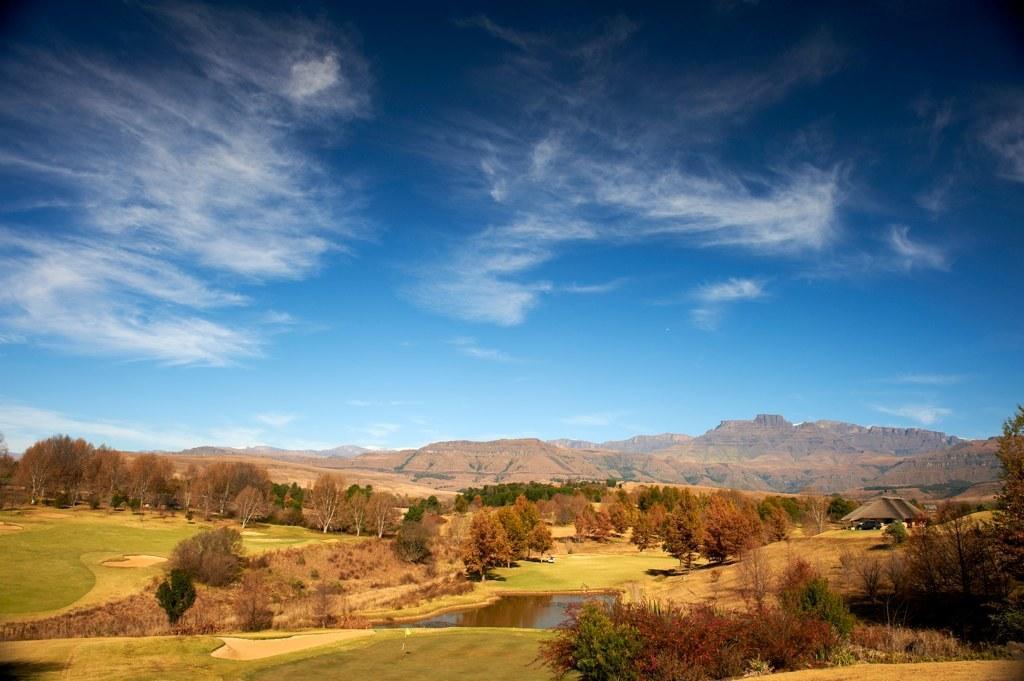Please provide a concise description of this image. In the center of the image there is water and we can see trees. In the background there are hills and sky. 